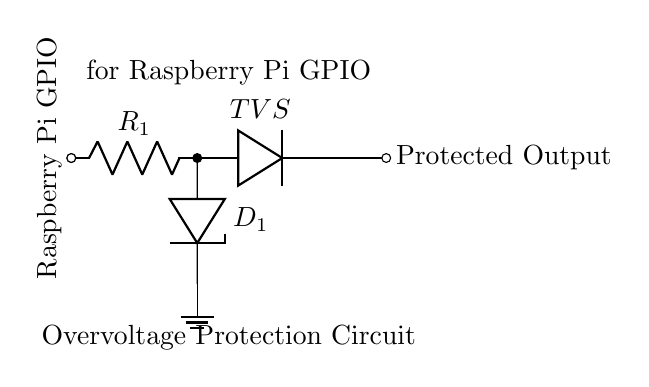What is the first component in the circuit? The first component in the circuit is a resistor, labeled R1, which is connected to the Raspberry Pi GPIO.
Answer: Resistor What does the TVS diode protect against? The TVS (Transient Voltage Suppressor) diode protects against voltage spikes that exceed a safe level, ensuring that excess voltage does not reach the Raspberry Pi GPIO.
Answer: Voltage spikes How many diodes are present in the circuit? There are two diodes in the circuit: one Zener diode labeled D1 and one TVS diode.
Answer: Two What is the purpose of the resistor labeled R1? The resistor R1 is used to limit the current flowing into the GPIO, helping to prevent damage by ensuring that the current does not exceed the maximum rating of the GPIO pin.
Answer: Limit current What happens if the voltage exceeds the breakdown voltage of the Zener diode D1? If the voltage exceeds the breakdown voltage of the Zener diode D1, it will conduct in the reverse direction, allowing excess voltage to be clamped to a safe level, protecting the GPIO.
Answer: Conduct and clamp What is the output of the circuit labeled as? The output of the circuit is labeled as "Protected Output," indicating that it provides a safe voltage signal to the connected load or circuit.
Answer: Protected Output Where is the ground connection in the circuit? The ground connection is located at the bottom of the circuit, directly attached to the Zener diode D1, indicating the reference point for the voltage levels in the circuit.
Answer: Bottom of the circuit 